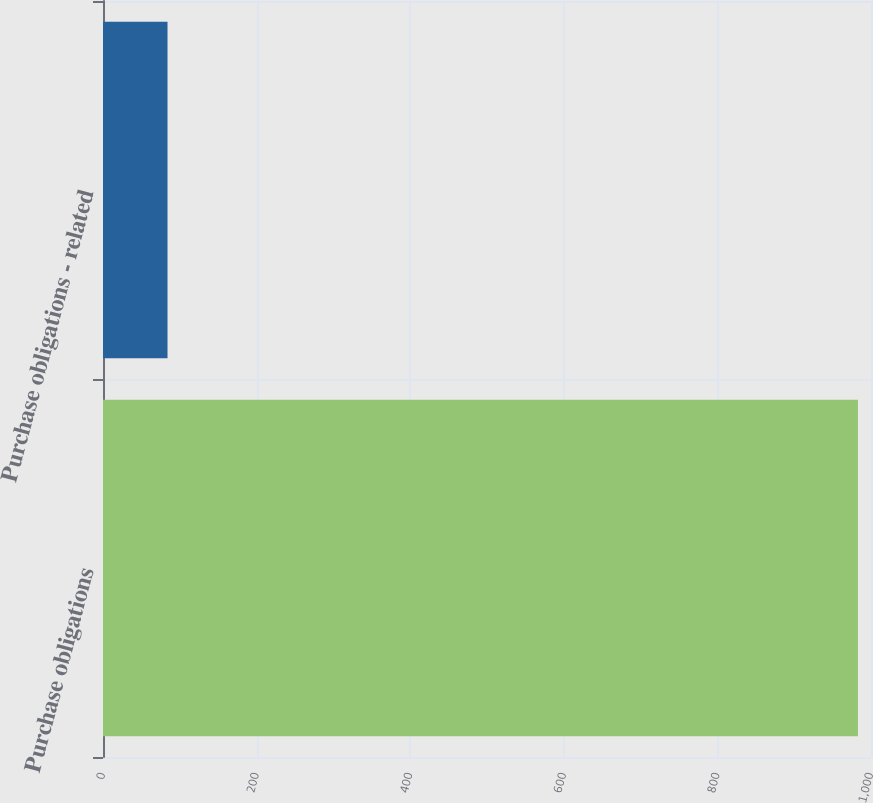<chart> <loc_0><loc_0><loc_500><loc_500><bar_chart><fcel>Purchase obligations<fcel>Purchase obligations - related<nl><fcel>983<fcel>84<nl></chart> 